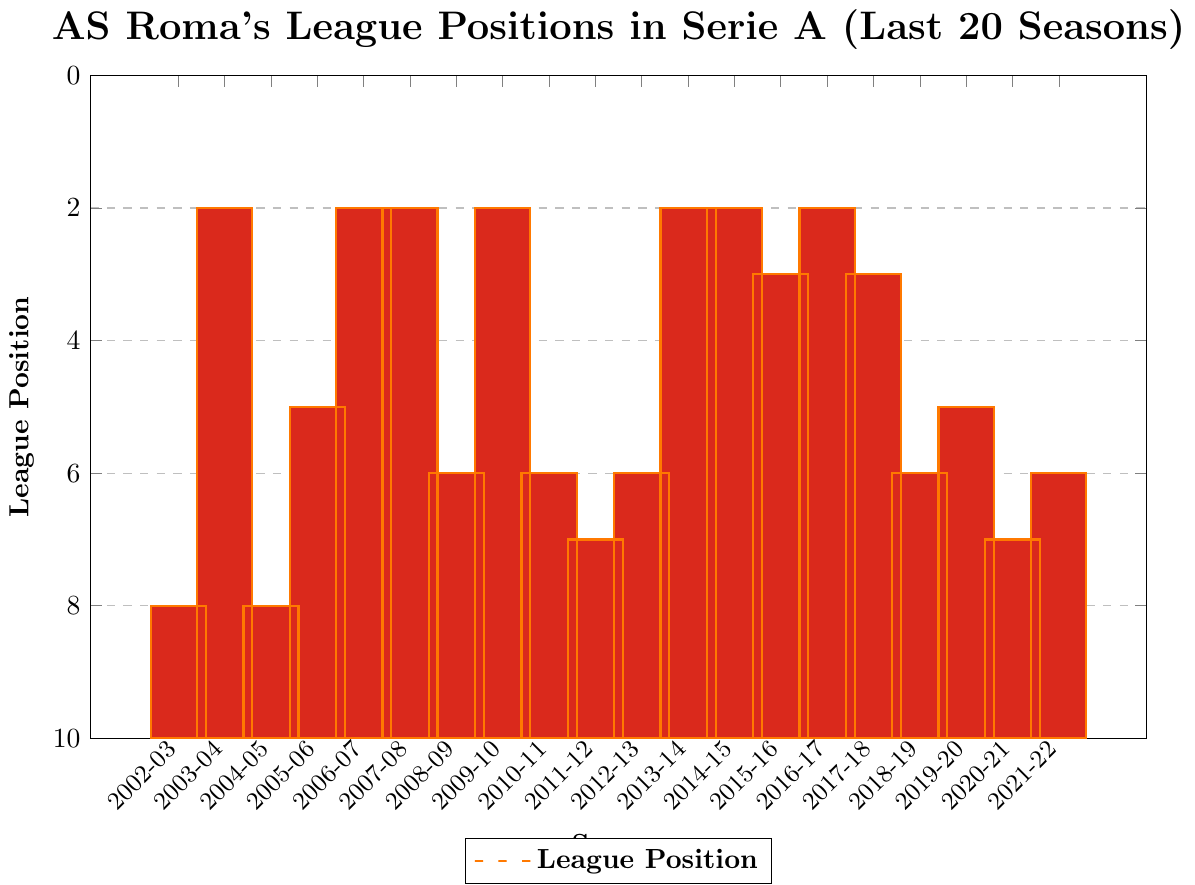Which season did AS Roma achieve their best league position in the given period? Look at the bar chart for the bar with the shortest height. This corresponds to the 2nd place, achieved in the seasons 2003-04, 2006-07, 2007-08, 2009-10, 2013-14, and 2014-15. Any of these seasons reflect their best position.
Answer: 2003-04, 2006-07, 2007-08, 2009-10, 2013-14, 2014-15 Which season did AS Roma have the lowest league position in the given period? Examine the bar chart and locate the bar with the greatest height, corresponding to the 8th position. This position was achieved in the seasons 2002-03, 2004-05, and 2011-12. Any of these seasons reflect their lowest position.
Answer: 2002-03, 2004-05, 2011-12 How many seasons did AS Roma finish in the top three positions? Count the number of bars with heights that correspond to positions 1, 2, or 3. The bars indicate that AS Roma achieved 2nd place 5 times and 3rd place twice, making a total of 7 times.
Answer: 7 In which seasons did AS Roma finish in the top three positions successively without interruption? Check for consecutive bars reflecting positions 1, 2, or 3. AS Roma finished in the top three successively in the seasons 2005-06 to 2007-08 and 2013-14 to 2015-16.
Answer: 2005-06 to 2007-08, 2013-14 to 2015-16 What is the average league position of AS Roma over the last 20 seasons? Sum the league positions given: 8 + 2 + 8 + 5 + 2 + 2 + 6 + 2 + 6 + 7 + 6 + 2 + 2 + 3 + 2 + 3 + 6 + 5 + 7 + 6 = 88. Divide this sum by the number of seasons, which is 20. Therefore, the average position is 88 / 20 = 4.4.
Answer: 4.4 How many seasons did AS Roma finish in 2nd place? Count the bars that are significantly low, indicating the 2nd position. There are 6 such bars: 2003-04, 2006-07, 2007-08, 2009-10, 2013-14, and 2014-15.
Answer: 6 